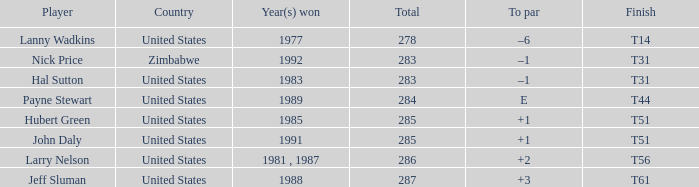Can you parse all the data within this table? {'header': ['Player', 'Country', 'Year(s) won', 'Total', 'To par', 'Finish'], 'rows': [['Lanny Wadkins', 'United States', '1977', '278', '–6', 'T14'], ['Nick Price', 'Zimbabwe', '1992', '283', '–1', 'T31'], ['Hal Sutton', 'United States', '1983', '283', '–1', 'T31'], ['Payne Stewart', 'United States', '1989', '284', 'E', 'T44'], ['Hubert Green', 'United States', '1985', '285', '+1', 'T51'], ['John Daly', 'United States', '1991', '285', '+1', 'T51'], ['Larry Nelson', 'United States', '1981 , 1987', '286', '+2', 'T56'], ['Jeff Sluman', 'United States', '1988', '287', '+3', 'T61']]} What is Year(s) Won, when Finish is "T31", and when Player is "Nick Price"? 1992.0. 